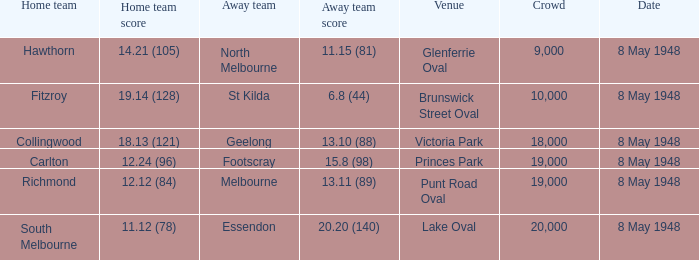Write the full table. {'header': ['Home team', 'Home team score', 'Away team', 'Away team score', 'Venue', 'Crowd', 'Date'], 'rows': [['Hawthorn', '14.21 (105)', 'North Melbourne', '11.15 (81)', 'Glenferrie Oval', '9,000', '8 May 1948'], ['Fitzroy', '19.14 (128)', 'St Kilda', '6.8 (44)', 'Brunswick Street Oval', '10,000', '8 May 1948'], ['Collingwood', '18.13 (121)', 'Geelong', '13.10 (88)', 'Victoria Park', '18,000', '8 May 1948'], ['Carlton', '12.24 (96)', 'Footscray', '15.8 (98)', 'Princes Park', '19,000', '8 May 1948'], ['Richmond', '12.12 (84)', 'Melbourne', '13.11 (89)', 'Punt Road Oval', '19,000', '8 May 1948'], ['South Melbourne', '11.12 (78)', 'Essendon', '20.20 (140)', 'Lake Oval', '20,000', '8 May 1948']]} Which home side has a score of 1 South Melbourne. 